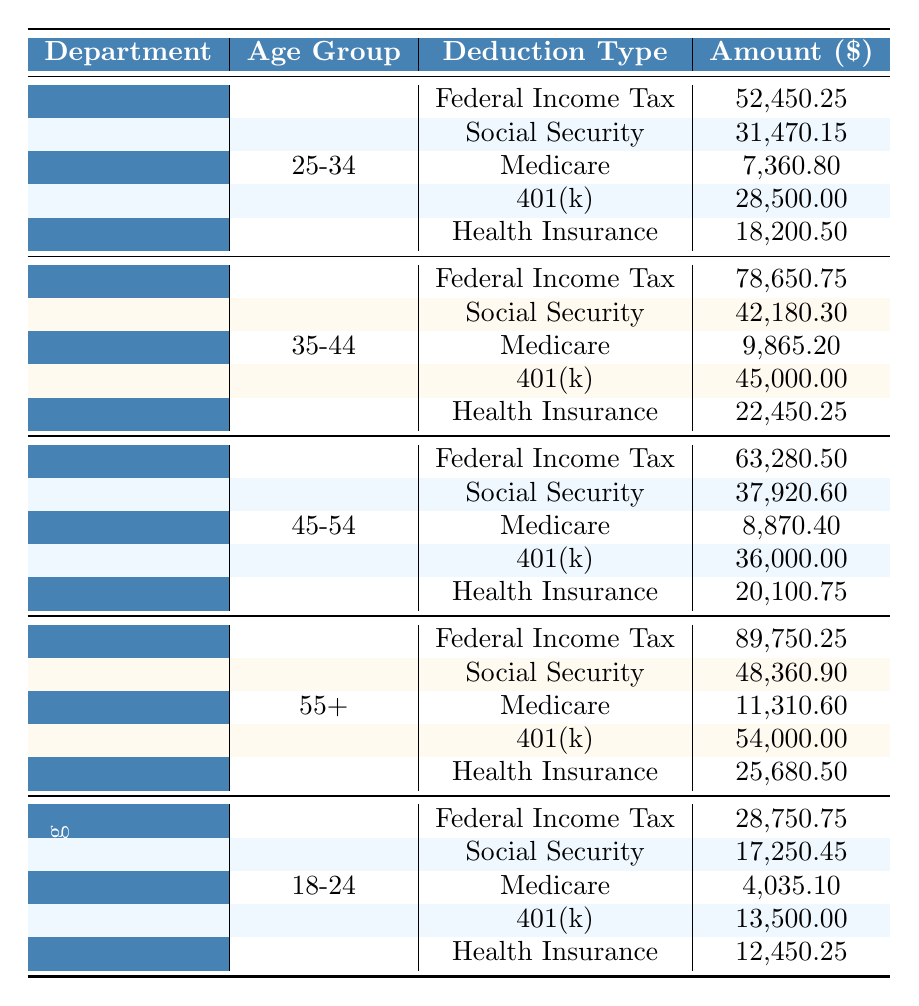What is the total amount of deductions for the IT department? To find the total deductions for the IT department, we need to sum the amounts of all the deduction types listed for that department: 78,650.75 (Federal Income Tax) + 42,180.30 (Social Security) + 9,865.20 (Medicare) + 45,000.00 (401(k)) + 22,450.25 (Health Insurance) = 198,146.70
Answer: 198,146.70 Which age group has the highest Federal Income Tax deduction? By comparing the Federal Income Tax amounts across all age groups, we see Sales has 52,450.25, IT has 78,650.75, HR has 63,280.50, Finance has 89,750.25, and Marketing has 28,750.75. Finance has the highest amount at 89,750.25.
Answer: Finance What is the average Health Insurance deduction across all departments? To calculate the average, add the Health Insurance deductions: 18,200.50 (Sales) + 22,450.25 (IT) + 20,100.75 (HR) + 25,680.50 (Finance) + 12,450.25 (Marketing) = 98,882.25. There are 5 departments, so the average is 98,882.25 / 5 = 19,776.45.
Answer: 19,776.45 Is the total amount of deductions for the HR department greater than that for the Sales department? The total deductions for HR (63,280.50 + 37,920.60 + 8,870.40 + 36,000.00 + 20,100.75 = 166,172.25) is compared with Sales (52,450.25 + 31,470.15 + 7,360.80 + 28,500.00 + 18,200.50 = 138,981.70). Since 166,172.25 > 138,981.70, the answer is yes.
Answer: Yes What is the difference in total deductions between the Finance and Marketing departments? First, calculate the total deductions for both departments. Finance total is 89,750.25 + 48,360.90 + 11,310.60 + 54,000.00 + 25,680.50 = 229,102.25. Marketing total is 28,750.75 + 17,250.45 + 4,035.10 + 13,500.00 + 12,450.25 = 75,986.55. The difference is 229,102.25 - 75,986.55 = 153,115.70.
Answer: 153,115.70 Which department has the highest total amount for 401(k) deductions? The 401(k) deductions are as follows: Sales has 28,500.00, IT has 45,000.00, HR has 36,000.00, Finance has 54,000.00, and Marketing has 13,500.00. Since 54,000.00 (Finance) is the highest, Finance is the answer.
Answer: Finance If we consider only the ages 25-34, what type of deduction has the highest amount? In the Sales department, for the age group 25-34, the deduction amounts are: Federal Income Tax 52,450.25, Social Security 31,470.15, Medicare 7,360.80, 401(k) 28,500.00, and Health Insurance 18,200.50. The highest is Federal Income Tax at 52,450.25.
Answer: Federal Income Tax What is the total amount of Medicare deductions across all age groups? The Medicare deductions from each department are: 7,360.80 (Sales) + 9,865.20 (IT) + 8,870.40 (HR) + 11,310.60 (Finance) + 4,035.10 (Marketing). Summing these gives 7,360.80 + 9,865.20 + 8,870.40 + 11,310.60 + 4,035.10 = 41,442.10.
Answer: 41,442.10 Is the amount for Health Insurance in the IT department greater than the Medicare amount in the same department? For IT, the Health Insurance amount is 22,450.25 and the Medicare amount is 9,865.20. Since 22,450.25 > 9,865.20, the answer is yes.
Answer: Yes Which department has the lowest total deductions? By calculating total deductions: Sales 138,981.70, IT 198,146.70, HR 166,172.25, Finance 229,102.25, Marketing 75,986.55. The lowest total is Marketing with 75,986.55.
Answer: Marketing What percentage of total deductions in the HR department comes from Social Security? The total deductions for HR is 166,172.25. The Social Security deduction is 37,920.60. To find the percentage, (37,920.60 / 166,172.25) * 100 ≈ 22.8%.
Answer: 22.8% 